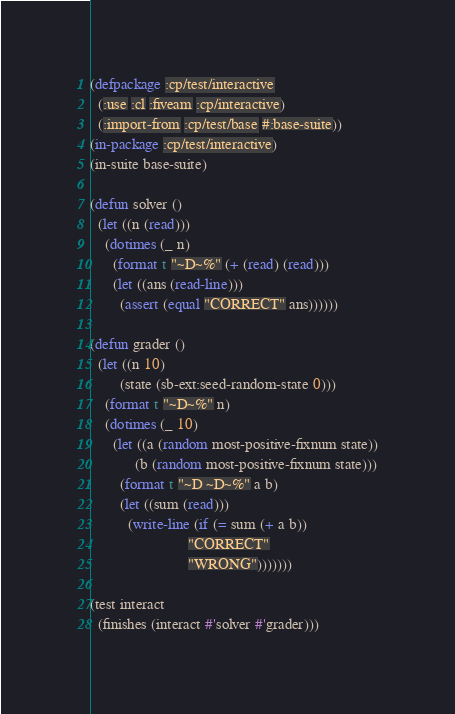Convert code to text. <code><loc_0><loc_0><loc_500><loc_500><_Lisp_>(defpackage :cp/test/interactive
  (:use :cl :fiveam :cp/interactive)
  (:import-from :cp/test/base #:base-suite))
(in-package :cp/test/interactive)
(in-suite base-suite)

(defun solver ()
  (let ((n (read)))
    (dotimes (_ n)
      (format t "~D~%" (+ (read) (read)))
      (let ((ans (read-line)))
        (assert (equal "CORRECT" ans))))))

(defun grader ()
  (let ((n 10)
        (state (sb-ext:seed-random-state 0)))
    (format t "~D~%" n)
    (dotimes (_ 10)
      (let ((a (random most-positive-fixnum state))
            (b (random most-positive-fixnum state)))
        (format t "~D ~D~%" a b)
        (let ((sum (read)))
          (write-line (if (= sum (+ a b))
                          "CORRECT"
                          "WRONG")))))))

(test interact
  (finishes (interact #'solver #'grader)))
</code> 